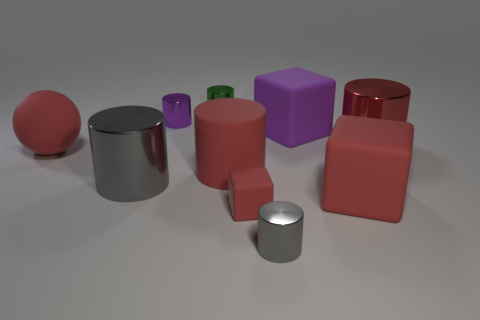Subtract all red blocks. How many gray cylinders are left? 2 Subtract all big gray cylinders. How many cylinders are left? 5 Subtract all green cylinders. How many cylinders are left? 5 Subtract 1 cylinders. How many cylinders are left? 5 Subtract all cylinders. How many objects are left? 4 Subtract all red cylinders. Subtract all green blocks. How many cylinders are left? 4 Add 3 green things. How many green things are left? 4 Add 9 purple rubber cubes. How many purple rubber cubes exist? 10 Subtract 0 blue cylinders. How many objects are left? 10 Subtract all purple cubes. Subtract all big metal cylinders. How many objects are left? 7 